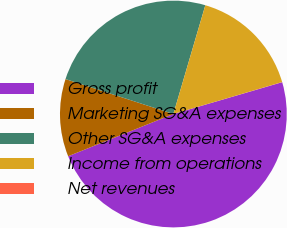<chart> <loc_0><loc_0><loc_500><loc_500><pie_chart><fcel>Gross profit<fcel>Marketing SG&A expenses<fcel>Other SG&A expenses<fcel>Income from operations<fcel>Net revenues<nl><fcel>48.45%<fcel>11.06%<fcel>24.56%<fcel>15.9%<fcel>0.02%<nl></chart> 